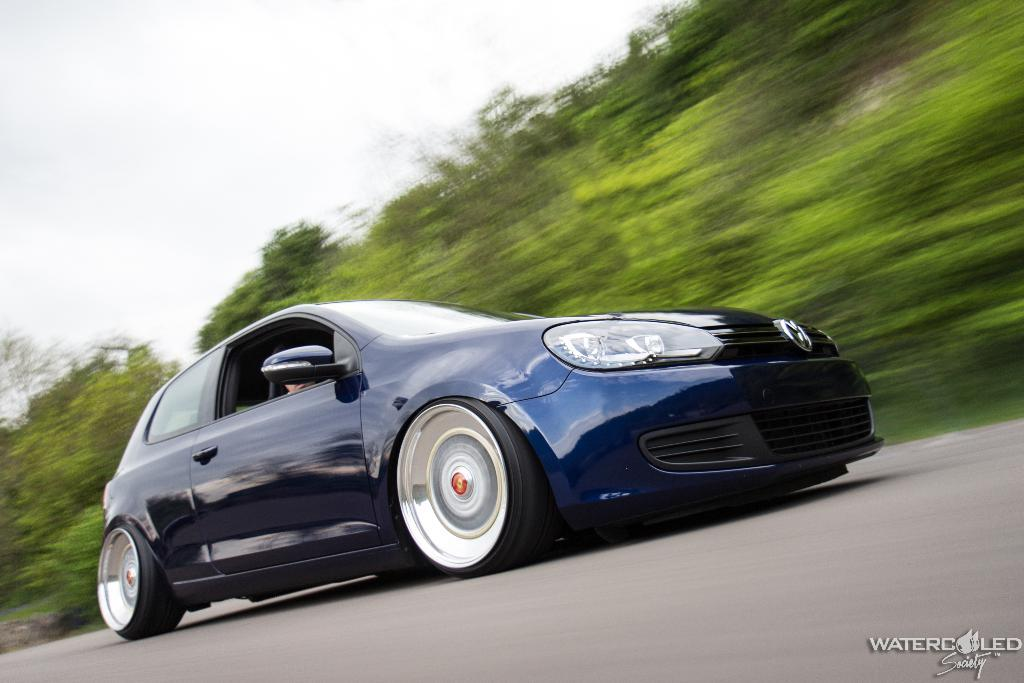What is the main subject of the image? There is a car in the image. What is the car doing in the image? The car is moving on a road. What can be seen in the background of the image? There are trees and the sky visible in the background of the image. How is the background of the image depicted? The background appears blurred. Is there any text present in the image? Yes, there is text in the bottom right corner of the image. What type of coach can be seen interacting with the car in the image? There is no coach present in the image; it only features a car moving on a road. What is the sister of the driver doing in the image? There is no information about a driver or a sister in the image, so it cannot be determined from the image. 